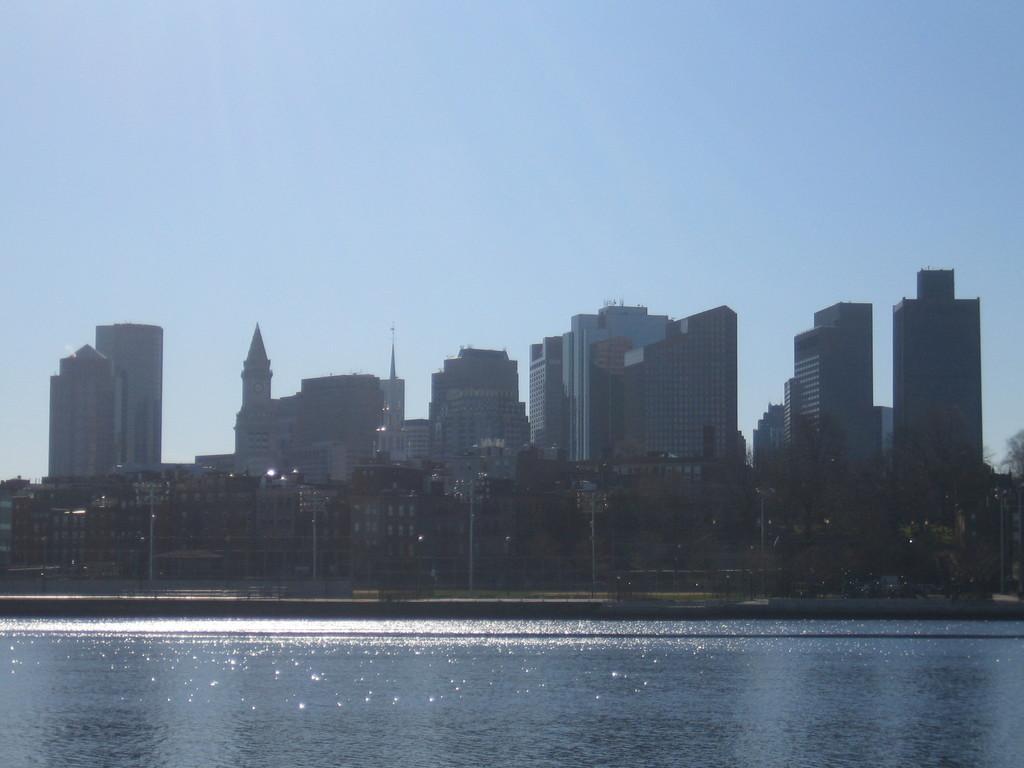Could you give a brief overview of what you see in this image? This is an outside view. At the bottom there is a sea. In the background there are many trees, poles and buildings. At the top of the image I can see the sky. 